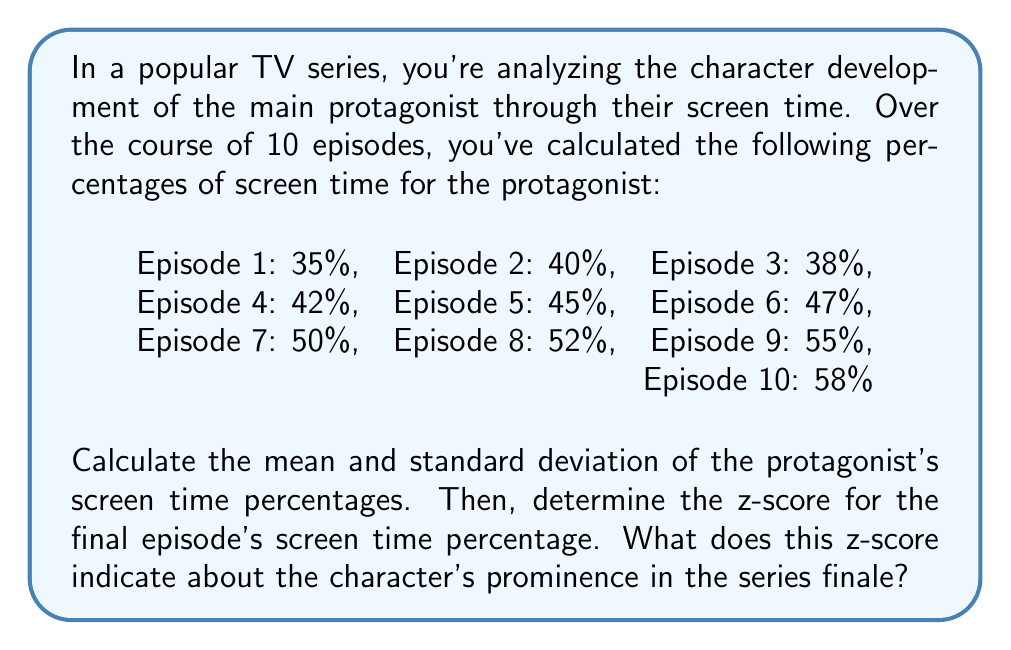Solve this math problem. To solve this problem, we'll follow these steps:

1. Calculate the mean (μ) of the screen time percentages:
   $$\mu = \frac{\sum_{i=1}^{n} x_i}{n}$$
   where $x_i$ are the individual percentages and $n$ is the number of episodes.

   $$\mu = \frac{35 + 40 + 38 + 42 + 45 + 47 + 50 + 52 + 55 + 58}{10} = \frac{462}{10} = 46.2\%$$

2. Calculate the standard deviation (σ):
   $$\sigma = \sqrt{\frac{\sum_{i=1}^{n} (x_i - \mu)^2}{n}}$$

   First, calculate $(x_i - \mu)^2$ for each episode:
   $$(35 - 46.2)^2 = 125.44$$
   $$(40 - 46.2)^2 = 38.44$$
   $$(38 - 46.2)^2 = 67.24$$
   $$(42 - 46.2)^2 = 17.64$$
   $$(45 - 46.2)^2 = 1.44$$
   $$(47 - 46.2)^2 = 0.64$$
   $$(50 - 46.2)^2 = 14.44$$
   $$(52 - 46.2)^2 = 33.64$$
   $$(55 - 46.2)^2 = 77.44$$
   $$(58 - 46.2)^2 = 139.24$$

   Sum these values and divide by n:
   $$\sigma = \sqrt{\frac{125.44 + 38.44 + 67.24 + 17.64 + 1.44 + 0.64 + 14.44 + 33.64 + 77.44 + 139.24}{10}}$$
   $$\sigma = \sqrt{\frac{515.6}{10}} = \sqrt{51.56} \approx 7.18\%$$

3. Calculate the z-score for the final episode (58%):
   $$z = \frac{x - \mu}{\sigma}$$
   where $x$ is the final episode's percentage, $\mu$ is the mean, and $\sigma$ is the standard deviation.

   $$z = \frac{58 - 46.2}{7.18} \approx 1.64$$

The z-score of 1.64 indicates that the protagonist's screen time in the final episode is 1.64 standard deviations above the mean. This suggests a significant increase in the character's prominence in the series finale, as it's well above the average screen time throughout the series.
Answer: Mean (μ) ≈ 46.2%, Standard Deviation (σ) ≈ 7.18%, Z-score for final episode ≈ 1.64

The z-score of 1.64 indicates that the protagonist's screen time in the final episode is significantly above average, suggesting increased prominence in the series finale. 